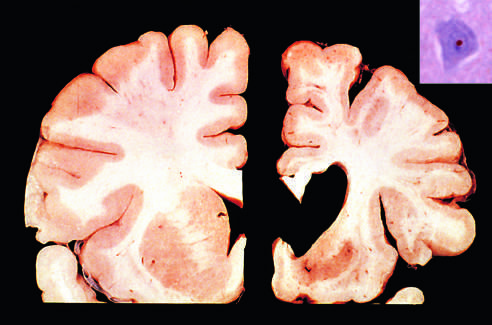s an intranuclear inclusion in a cortical neuron strongly immunoreactive for ubiquitin?
Answer the question using a single word or phrase. Yes 